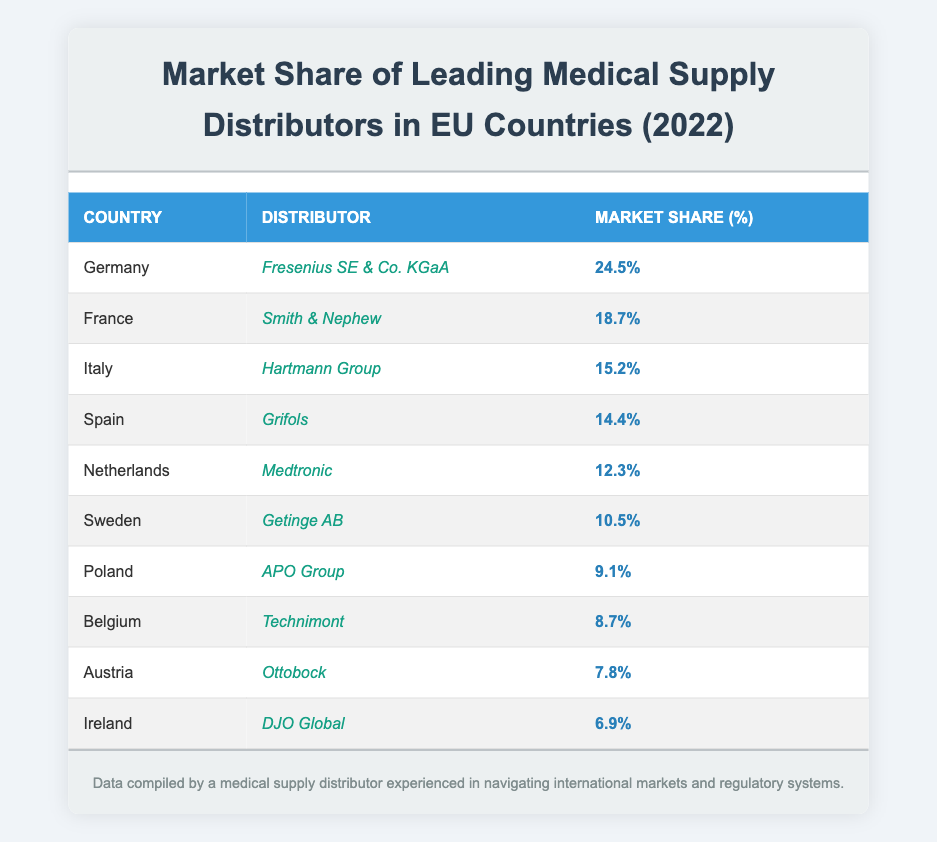What is the market share percentage of Fresenius SE & Co. KGaA in Germany? The table shows that the market share percentage for Fresenius SE & Co. KGaA in Germany is 24.5%.
Answer: 24.5% Which distributor has the highest market share in the EU? Fresenius SE & Co. KGaA has the highest market share of 24.5% in Germany, which is the largest in the EU according to the table.
Answer: Fresenius SE & Co. KGaA What is the market share percentage of Smith & Nephew in France? The table indicates that Smith & Nephew has a market share percentage of 18.7% in France.
Answer: 18.7% Which country has the lowest market share among the listed distributors? According to the table, Ireland has the lowest market share with DJO Global holding 6.9%.
Answer: Ireland What is the combined market share of Hartmann Group and Grifols? Hartmann Group has a market share of 15.2% in Italy, while Grifols has 14.4% in Spain. Adding these gives 15.2% + 14.4% = 29.6%.
Answer: 29.6% Is the market share of Technimont in Belgium greater than that of APO Group in Poland? Technimont has a market share of 8.7% in Belgium, while APO Group has a market share of 9.1% in Poland. Comparing these values shows that 8.7% is less than 9.1%.
Answer: No What is the average market share of the top three distributors listed? The top three distributors are Fresenius SE & Co. KGaA (24.5%), Smith & Nephew (18.7%), and Hartmann Group (15.2%). Calculating the average gives (24.5% + 18.7% + 15.2%) / 3 = 19.4667%, which is approximately 19.5%.
Answer: 19.5% Calculating the total market share of all the distributors listed, what is that number? Adding the market shares of all distributors: 24.5% + 18.7% + 15.2% + 14.4% + 12.3% + 10.5% + 9.1% + 8.7% + 7.8% + 6.9% equals  150.1%.
Answer: 150.1% Is Medtronic in the top five distributors by market share? Reviewing the table, Medtronic has a market share of 12.3%, which ranks fifth out of the ten distributors listed.
Answer: Yes What percentage of the market share does Getinge AB hold in Sweden, and how does it compare to the market share of DJO Global in Ireland? Getinge AB holds a market share of 10.5% in Sweden, while DJO Global has 6.9% in Ireland. Comparing these values shows that 10.5% is greater than 6.9%.
Answer: Getinge AB has a higher market share 